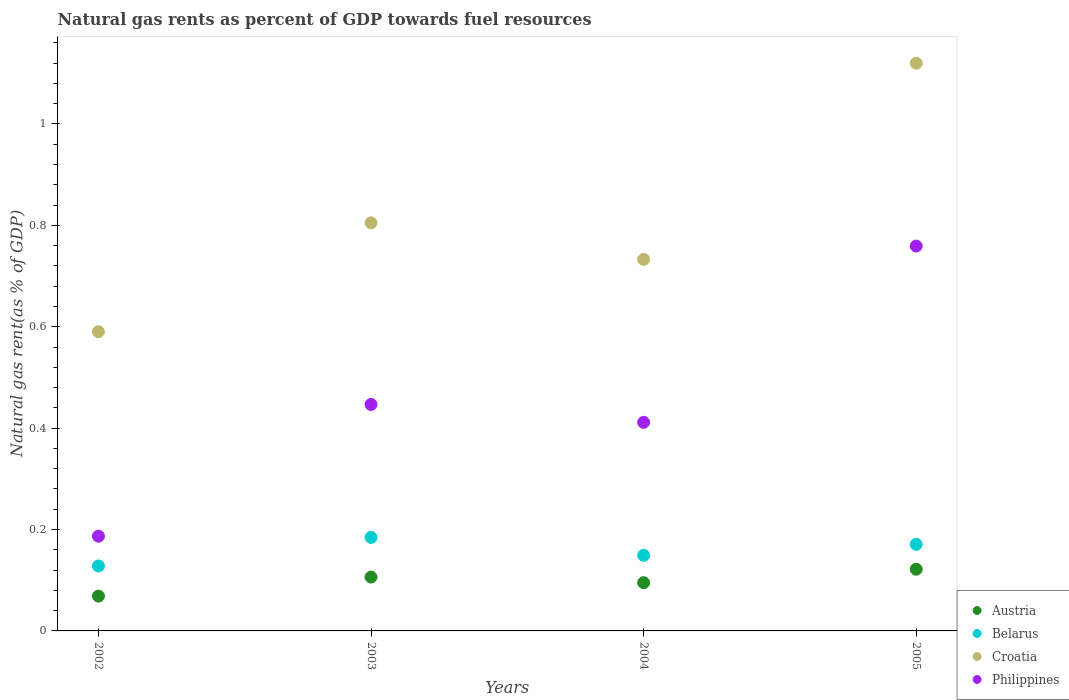Is the number of dotlines equal to the number of legend labels?
Keep it short and to the point. Yes. What is the natural gas rent in Austria in 2005?
Your answer should be compact. 0.12. Across all years, what is the maximum natural gas rent in Croatia?
Provide a short and direct response. 1.12. Across all years, what is the minimum natural gas rent in Belarus?
Ensure brevity in your answer.  0.13. In which year was the natural gas rent in Austria maximum?
Your answer should be very brief. 2005. What is the total natural gas rent in Croatia in the graph?
Provide a succinct answer. 3.25. What is the difference between the natural gas rent in Austria in 2003 and that in 2005?
Keep it short and to the point. -0.02. What is the difference between the natural gas rent in Belarus in 2003 and the natural gas rent in Croatia in 2005?
Make the answer very short. -0.94. What is the average natural gas rent in Austria per year?
Keep it short and to the point. 0.1. In the year 2004, what is the difference between the natural gas rent in Belarus and natural gas rent in Philippines?
Offer a terse response. -0.26. In how many years, is the natural gas rent in Croatia greater than 0.52 %?
Your answer should be compact. 4. What is the ratio of the natural gas rent in Philippines in 2003 to that in 2004?
Give a very brief answer. 1.09. Is the difference between the natural gas rent in Belarus in 2002 and 2004 greater than the difference between the natural gas rent in Philippines in 2002 and 2004?
Your response must be concise. Yes. What is the difference between the highest and the second highest natural gas rent in Austria?
Offer a terse response. 0.02. What is the difference between the highest and the lowest natural gas rent in Croatia?
Your response must be concise. 0.53. Is it the case that in every year, the sum of the natural gas rent in Austria and natural gas rent in Croatia  is greater than the sum of natural gas rent in Belarus and natural gas rent in Philippines?
Provide a succinct answer. Yes. Is it the case that in every year, the sum of the natural gas rent in Belarus and natural gas rent in Croatia  is greater than the natural gas rent in Austria?
Your response must be concise. Yes. How many dotlines are there?
Your response must be concise. 4. How many years are there in the graph?
Keep it short and to the point. 4. Does the graph contain grids?
Your answer should be very brief. No. How many legend labels are there?
Your answer should be very brief. 4. How are the legend labels stacked?
Keep it short and to the point. Vertical. What is the title of the graph?
Ensure brevity in your answer.  Natural gas rents as percent of GDP towards fuel resources. What is the label or title of the X-axis?
Keep it short and to the point. Years. What is the label or title of the Y-axis?
Provide a succinct answer. Natural gas rent(as % of GDP). What is the Natural gas rent(as % of GDP) in Austria in 2002?
Give a very brief answer. 0.07. What is the Natural gas rent(as % of GDP) in Belarus in 2002?
Offer a terse response. 0.13. What is the Natural gas rent(as % of GDP) of Croatia in 2002?
Your answer should be very brief. 0.59. What is the Natural gas rent(as % of GDP) in Philippines in 2002?
Ensure brevity in your answer.  0.19. What is the Natural gas rent(as % of GDP) of Austria in 2003?
Your response must be concise. 0.11. What is the Natural gas rent(as % of GDP) of Belarus in 2003?
Keep it short and to the point. 0.18. What is the Natural gas rent(as % of GDP) of Croatia in 2003?
Give a very brief answer. 0.8. What is the Natural gas rent(as % of GDP) in Philippines in 2003?
Your answer should be very brief. 0.45. What is the Natural gas rent(as % of GDP) in Austria in 2004?
Offer a very short reply. 0.1. What is the Natural gas rent(as % of GDP) in Belarus in 2004?
Ensure brevity in your answer.  0.15. What is the Natural gas rent(as % of GDP) of Croatia in 2004?
Your answer should be very brief. 0.73. What is the Natural gas rent(as % of GDP) of Philippines in 2004?
Your answer should be compact. 0.41. What is the Natural gas rent(as % of GDP) of Austria in 2005?
Offer a very short reply. 0.12. What is the Natural gas rent(as % of GDP) of Belarus in 2005?
Ensure brevity in your answer.  0.17. What is the Natural gas rent(as % of GDP) of Croatia in 2005?
Offer a terse response. 1.12. What is the Natural gas rent(as % of GDP) in Philippines in 2005?
Your answer should be compact. 0.76. Across all years, what is the maximum Natural gas rent(as % of GDP) in Austria?
Make the answer very short. 0.12. Across all years, what is the maximum Natural gas rent(as % of GDP) in Belarus?
Provide a short and direct response. 0.18. Across all years, what is the maximum Natural gas rent(as % of GDP) in Croatia?
Ensure brevity in your answer.  1.12. Across all years, what is the maximum Natural gas rent(as % of GDP) of Philippines?
Your answer should be very brief. 0.76. Across all years, what is the minimum Natural gas rent(as % of GDP) of Austria?
Your response must be concise. 0.07. Across all years, what is the minimum Natural gas rent(as % of GDP) in Belarus?
Your response must be concise. 0.13. Across all years, what is the minimum Natural gas rent(as % of GDP) of Croatia?
Ensure brevity in your answer.  0.59. Across all years, what is the minimum Natural gas rent(as % of GDP) in Philippines?
Provide a succinct answer. 0.19. What is the total Natural gas rent(as % of GDP) of Austria in the graph?
Your answer should be very brief. 0.39. What is the total Natural gas rent(as % of GDP) in Belarus in the graph?
Your answer should be compact. 0.63. What is the total Natural gas rent(as % of GDP) in Croatia in the graph?
Offer a terse response. 3.25. What is the total Natural gas rent(as % of GDP) in Philippines in the graph?
Your answer should be very brief. 1.8. What is the difference between the Natural gas rent(as % of GDP) in Austria in 2002 and that in 2003?
Give a very brief answer. -0.04. What is the difference between the Natural gas rent(as % of GDP) of Belarus in 2002 and that in 2003?
Your response must be concise. -0.06. What is the difference between the Natural gas rent(as % of GDP) of Croatia in 2002 and that in 2003?
Provide a succinct answer. -0.21. What is the difference between the Natural gas rent(as % of GDP) of Philippines in 2002 and that in 2003?
Your answer should be compact. -0.26. What is the difference between the Natural gas rent(as % of GDP) of Austria in 2002 and that in 2004?
Ensure brevity in your answer.  -0.03. What is the difference between the Natural gas rent(as % of GDP) in Belarus in 2002 and that in 2004?
Your response must be concise. -0.02. What is the difference between the Natural gas rent(as % of GDP) of Croatia in 2002 and that in 2004?
Your response must be concise. -0.14. What is the difference between the Natural gas rent(as % of GDP) of Philippines in 2002 and that in 2004?
Keep it short and to the point. -0.22. What is the difference between the Natural gas rent(as % of GDP) in Austria in 2002 and that in 2005?
Ensure brevity in your answer.  -0.05. What is the difference between the Natural gas rent(as % of GDP) in Belarus in 2002 and that in 2005?
Your answer should be very brief. -0.04. What is the difference between the Natural gas rent(as % of GDP) in Croatia in 2002 and that in 2005?
Ensure brevity in your answer.  -0.53. What is the difference between the Natural gas rent(as % of GDP) in Philippines in 2002 and that in 2005?
Keep it short and to the point. -0.57. What is the difference between the Natural gas rent(as % of GDP) of Austria in 2003 and that in 2004?
Make the answer very short. 0.01. What is the difference between the Natural gas rent(as % of GDP) of Belarus in 2003 and that in 2004?
Your answer should be compact. 0.04. What is the difference between the Natural gas rent(as % of GDP) of Croatia in 2003 and that in 2004?
Provide a short and direct response. 0.07. What is the difference between the Natural gas rent(as % of GDP) in Philippines in 2003 and that in 2004?
Provide a short and direct response. 0.04. What is the difference between the Natural gas rent(as % of GDP) in Austria in 2003 and that in 2005?
Make the answer very short. -0.02. What is the difference between the Natural gas rent(as % of GDP) of Belarus in 2003 and that in 2005?
Your answer should be compact. 0.01. What is the difference between the Natural gas rent(as % of GDP) of Croatia in 2003 and that in 2005?
Your answer should be very brief. -0.31. What is the difference between the Natural gas rent(as % of GDP) in Philippines in 2003 and that in 2005?
Give a very brief answer. -0.31. What is the difference between the Natural gas rent(as % of GDP) in Austria in 2004 and that in 2005?
Offer a very short reply. -0.03. What is the difference between the Natural gas rent(as % of GDP) of Belarus in 2004 and that in 2005?
Your answer should be very brief. -0.02. What is the difference between the Natural gas rent(as % of GDP) of Croatia in 2004 and that in 2005?
Your answer should be very brief. -0.39. What is the difference between the Natural gas rent(as % of GDP) in Philippines in 2004 and that in 2005?
Make the answer very short. -0.35. What is the difference between the Natural gas rent(as % of GDP) in Austria in 2002 and the Natural gas rent(as % of GDP) in Belarus in 2003?
Provide a succinct answer. -0.12. What is the difference between the Natural gas rent(as % of GDP) of Austria in 2002 and the Natural gas rent(as % of GDP) of Croatia in 2003?
Offer a very short reply. -0.74. What is the difference between the Natural gas rent(as % of GDP) in Austria in 2002 and the Natural gas rent(as % of GDP) in Philippines in 2003?
Provide a succinct answer. -0.38. What is the difference between the Natural gas rent(as % of GDP) of Belarus in 2002 and the Natural gas rent(as % of GDP) of Croatia in 2003?
Provide a short and direct response. -0.68. What is the difference between the Natural gas rent(as % of GDP) in Belarus in 2002 and the Natural gas rent(as % of GDP) in Philippines in 2003?
Offer a very short reply. -0.32. What is the difference between the Natural gas rent(as % of GDP) in Croatia in 2002 and the Natural gas rent(as % of GDP) in Philippines in 2003?
Provide a short and direct response. 0.14. What is the difference between the Natural gas rent(as % of GDP) in Austria in 2002 and the Natural gas rent(as % of GDP) in Belarus in 2004?
Your response must be concise. -0.08. What is the difference between the Natural gas rent(as % of GDP) in Austria in 2002 and the Natural gas rent(as % of GDP) in Croatia in 2004?
Ensure brevity in your answer.  -0.66. What is the difference between the Natural gas rent(as % of GDP) of Austria in 2002 and the Natural gas rent(as % of GDP) of Philippines in 2004?
Provide a succinct answer. -0.34. What is the difference between the Natural gas rent(as % of GDP) in Belarus in 2002 and the Natural gas rent(as % of GDP) in Croatia in 2004?
Your response must be concise. -0.6. What is the difference between the Natural gas rent(as % of GDP) of Belarus in 2002 and the Natural gas rent(as % of GDP) of Philippines in 2004?
Offer a terse response. -0.28. What is the difference between the Natural gas rent(as % of GDP) of Croatia in 2002 and the Natural gas rent(as % of GDP) of Philippines in 2004?
Make the answer very short. 0.18. What is the difference between the Natural gas rent(as % of GDP) of Austria in 2002 and the Natural gas rent(as % of GDP) of Belarus in 2005?
Make the answer very short. -0.1. What is the difference between the Natural gas rent(as % of GDP) of Austria in 2002 and the Natural gas rent(as % of GDP) of Croatia in 2005?
Keep it short and to the point. -1.05. What is the difference between the Natural gas rent(as % of GDP) of Austria in 2002 and the Natural gas rent(as % of GDP) of Philippines in 2005?
Your answer should be very brief. -0.69. What is the difference between the Natural gas rent(as % of GDP) of Belarus in 2002 and the Natural gas rent(as % of GDP) of Croatia in 2005?
Offer a very short reply. -0.99. What is the difference between the Natural gas rent(as % of GDP) in Belarus in 2002 and the Natural gas rent(as % of GDP) in Philippines in 2005?
Provide a short and direct response. -0.63. What is the difference between the Natural gas rent(as % of GDP) in Croatia in 2002 and the Natural gas rent(as % of GDP) in Philippines in 2005?
Your answer should be very brief. -0.17. What is the difference between the Natural gas rent(as % of GDP) of Austria in 2003 and the Natural gas rent(as % of GDP) of Belarus in 2004?
Provide a succinct answer. -0.04. What is the difference between the Natural gas rent(as % of GDP) of Austria in 2003 and the Natural gas rent(as % of GDP) of Croatia in 2004?
Give a very brief answer. -0.63. What is the difference between the Natural gas rent(as % of GDP) of Austria in 2003 and the Natural gas rent(as % of GDP) of Philippines in 2004?
Your answer should be compact. -0.31. What is the difference between the Natural gas rent(as % of GDP) of Belarus in 2003 and the Natural gas rent(as % of GDP) of Croatia in 2004?
Make the answer very short. -0.55. What is the difference between the Natural gas rent(as % of GDP) in Belarus in 2003 and the Natural gas rent(as % of GDP) in Philippines in 2004?
Your response must be concise. -0.23. What is the difference between the Natural gas rent(as % of GDP) in Croatia in 2003 and the Natural gas rent(as % of GDP) in Philippines in 2004?
Provide a short and direct response. 0.39. What is the difference between the Natural gas rent(as % of GDP) in Austria in 2003 and the Natural gas rent(as % of GDP) in Belarus in 2005?
Give a very brief answer. -0.06. What is the difference between the Natural gas rent(as % of GDP) in Austria in 2003 and the Natural gas rent(as % of GDP) in Croatia in 2005?
Your answer should be very brief. -1.01. What is the difference between the Natural gas rent(as % of GDP) of Austria in 2003 and the Natural gas rent(as % of GDP) of Philippines in 2005?
Give a very brief answer. -0.65. What is the difference between the Natural gas rent(as % of GDP) of Belarus in 2003 and the Natural gas rent(as % of GDP) of Croatia in 2005?
Provide a succinct answer. -0.94. What is the difference between the Natural gas rent(as % of GDP) in Belarus in 2003 and the Natural gas rent(as % of GDP) in Philippines in 2005?
Make the answer very short. -0.57. What is the difference between the Natural gas rent(as % of GDP) in Croatia in 2003 and the Natural gas rent(as % of GDP) in Philippines in 2005?
Give a very brief answer. 0.05. What is the difference between the Natural gas rent(as % of GDP) in Austria in 2004 and the Natural gas rent(as % of GDP) in Belarus in 2005?
Your response must be concise. -0.08. What is the difference between the Natural gas rent(as % of GDP) of Austria in 2004 and the Natural gas rent(as % of GDP) of Croatia in 2005?
Make the answer very short. -1.02. What is the difference between the Natural gas rent(as % of GDP) in Austria in 2004 and the Natural gas rent(as % of GDP) in Philippines in 2005?
Keep it short and to the point. -0.66. What is the difference between the Natural gas rent(as % of GDP) of Belarus in 2004 and the Natural gas rent(as % of GDP) of Croatia in 2005?
Keep it short and to the point. -0.97. What is the difference between the Natural gas rent(as % of GDP) in Belarus in 2004 and the Natural gas rent(as % of GDP) in Philippines in 2005?
Your answer should be compact. -0.61. What is the difference between the Natural gas rent(as % of GDP) of Croatia in 2004 and the Natural gas rent(as % of GDP) of Philippines in 2005?
Make the answer very short. -0.03. What is the average Natural gas rent(as % of GDP) of Austria per year?
Offer a terse response. 0.1. What is the average Natural gas rent(as % of GDP) of Belarus per year?
Give a very brief answer. 0.16. What is the average Natural gas rent(as % of GDP) of Croatia per year?
Provide a succinct answer. 0.81. What is the average Natural gas rent(as % of GDP) of Philippines per year?
Make the answer very short. 0.45. In the year 2002, what is the difference between the Natural gas rent(as % of GDP) of Austria and Natural gas rent(as % of GDP) of Belarus?
Ensure brevity in your answer.  -0.06. In the year 2002, what is the difference between the Natural gas rent(as % of GDP) in Austria and Natural gas rent(as % of GDP) in Croatia?
Keep it short and to the point. -0.52. In the year 2002, what is the difference between the Natural gas rent(as % of GDP) in Austria and Natural gas rent(as % of GDP) in Philippines?
Give a very brief answer. -0.12. In the year 2002, what is the difference between the Natural gas rent(as % of GDP) in Belarus and Natural gas rent(as % of GDP) in Croatia?
Make the answer very short. -0.46. In the year 2002, what is the difference between the Natural gas rent(as % of GDP) of Belarus and Natural gas rent(as % of GDP) of Philippines?
Your response must be concise. -0.06. In the year 2002, what is the difference between the Natural gas rent(as % of GDP) in Croatia and Natural gas rent(as % of GDP) in Philippines?
Your response must be concise. 0.4. In the year 2003, what is the difference between the Natural gas rent(as % of GDP) of Austria and Natural gas rent(as % of GDP) of Belarus?
Provide a short and direct response. -0.08. In the year 2003, what is the difference between the Natural gas rent(as % of GDP) in Austria and Natural gas rent(as % of GDP) in Croatia?
Make the answer very short. -0.7. In the year 2003, what is the difference between the Natural gas rent(as % of GDP) of Austria and Natural gas rent(as % of GDP) of Philippines?
Offer a very short reply. -0.34. In the year 2003, what is the difference between the Natural gas rent(as % of GDP) of Belarus and Natural gas rent(as % of GDP) of Croatia?
Your response must be concise. -0.62. In the year 2003, what is the difference between the Natural gas rent(as % of GDP) in Belarus and Natural gas rent(as % of GDP) in Philippines?
Give a very brief answer. -0.26. In the year 2003, what is the difference between the Natural gas rent(as % of GDP) in Croatia and Natural gas rent(as % of GDP) in Philippines?
Make the answer very short. 0.36. In the year 2004, what is the difference between the Natural gas rent(as % of GDP) of Austria and Natural gas rent(as % of GDP) of Belarus?
Offer a very short reply. -0.05. In the year 2004, what is the difference between the Natural gas rent(as % of GDP) of Austria and Natural gas rent(as % of GDP) of Croatia?
Offer a terse response. -0.64. In the year 2004, what is the difference between the Natural gas rent(as % of GDP) of Austria and Natural gas rent(as % of GDP) of Philippines?
Make the answer very short. -0.32. In the year 2004, what is the difference between the Natural gas rent(as % of GDP) in Belarus and Natural gas rent(as % of GDP) in Croatia?
Keep it short and to the point. -0.58. In the year 2004, what is the difference between the Natural gas rent(as % of GDP) in Belarus and Natural gas rent(as % of GDP) in Philippines?
Your answer should be compact. -0.26. In the year 2004, what is the difference between the Natural gas rent(as % of GDP) in Croatia and Natural gas rent(as % of GDP) in Philippines?
Your answer should be compact. 0.32. In the year 2005, what is the difference between the Natural gas rent(as % of GDP) in Austria and Natural gas rent(as % of GDP) in Belarus?
Provide a short and direct response. -0.05. In the year 2005, what is the difference between the Natural gas rent(as % of GDP) in Austria and Natural gas rent(as % of GDP) in Croatia?
Provide a short and direct response. -1. In the year 2005, what is the difference between the Natural gas rent(as % of GDP) of Austria and Natural gas rent(as % of GDP) of Philippines?
Your answer should be very brief. -0.64. In the year 2005, what is the difference between the Natural gas rent(as % of GDP) in Belarus and Natural gas rent(as % of GDP) in Croatia?
Give a very brief answer. -0.95. In the year 2005, what is the difference between the Natural gas rent(as % of GDP) in Belarus and Natural gas rent(as % of GDP) in Philippines?
Give a very brief answer. -0.59. In the year 2005, what is the difference between the Natural gas rent(as % of GDP) in Croatia and Natural gas rent(as % of GDP) in Philippines?
Ensure brevity in your answer.  0.36. What is the ratio of the Natural gas rent(as % of GDP) of Austria in 2002 to that in 2003?
Give a very brief answer. 0.65. What is the ratio of the Natural gas rent(as % of GDP) of Belarus in 2002 to that in 2003?
Provide a succinct answer. 0.69. What is the ratio of the Natural gas rent(as % of GDP) in Croatia in 2002 to that in 2003?
Offer a very short reply. 0.73. What is the ratio of the Natural gas rent(as % of GDP) of Philippines in 2002 to that in 2003?
Your answer should be very brief. 0.42. What is the ratio of the Natural gas rent(as % of GDP) in Austria in 2002 to that in 2004?
Keep it short and to the point. 0.72. What is the ratio of the Natural gas rent(as % of GDP) in Belarus in 2002 to that in 2004?
Your answer should be compact. 0.86. What is the ratio of the Natural gas rent(as % of GDP) in Croatia in 2002 to that in 2004?
Offer a terse response. 0.81. What is the ratio of the Natural gas rent(as % of GDP) in Philippines in 2002 to that in 2004?
Offer a very short reply. 0.45. What is the ratio of the Natural gas rent(as % of GDP) of Austria in 2002 to that in 2005?
Your answer should be very brief. 0.56. What is the ratio of the Natural gas rent(as % of GDP) of Belarus in 2002 to that in 2005?
Keep it short and to the point. 0.75. What is the ratio of the Natural gas rent(as % of GDP) of Croatia in 2002 to that in 2005?
Your answer should be compact. 0.53. What is the ratio of the Natural gas rent(as % of GDP) of Philippines in 2002 to that in 2005?
Ensure brevity in your answer.  0.25. What is the ratio of the Natural gas rent(as % of GDP) in Austria in 2003 to that in 2004?
Offer a very short reply. 1.12. What is the ratio of the Natural gas rent(as % of GDP) in Belarus in 2003 to that in 2004?
Your answer should be very brief. 1.24. What is the ratio of the Natural gas rent(as % of GDP) in Croatia in 2003 to that in 2004?
Your response must be concise. 1.1. What is the ratio of the Natural gas rent(as % of GDP) of Philippines in 2003 to that in 2004?
Offer a very short reply. 1.09. What is the ratio of the Natural gas rent(as % of GDP) of Austria in 2003 to that in 2005?
Your answer should be very brief. 0.87. What is the ratio of the Natural gas rent(as % of GDP) of Croatia in 2003 to that in 2005?
Give a very brief answer. 0.72. What is the ratio of the Natural gas rent(as % of GDP) of Philippines in 2003 to that in 2005?
Make the answer very short. 0.59. What is the ratio of the Natural gas rent(as % of GDP) in Austria in 2004 to that in 2005?
Keep it short and to the point. 0.78. What is the ratio of the Natural gas rent(as % of GDP) of Belarus in 2004 to that in 2005?
Ensure brevity in your answer.  0.87. What is the ratio of the Natural gas rent(as % of GDP) of Croatia in 2004 to that in 2005?
Offer a terse response. 0.65. What is the ratio of the Natural gas rent(as % of GDP) in Philippines in 2004 to that in 2005?
Your response must be concise. 0.54. What is the difference between the highest and the second highest Natural gas rent(as % of GDP) in Austria?
Offer a very short reply. 0.02. What is the difference between the highest and the second highest Natural gas rent(as % of GDP) of Belarus?
Your answer should be compact. 0.01. What is the difference between the highest and the second highest Natural gas rent(as % of GDP) of Croatia?
Your answer should be very brief. 0.31. What is the difference between the highest and the second highest Natural gas rent(as % of GDP) of Philippines?
Your response must be concise. 0.31. What is the difference between the highest and the lowest Natural gas rent(as % of GDP) of Austria?
Keep it short and to the point. 0.05. What is the difference between the highest and the lowest Natural gas rent(as % of GDP) of Belarus?
Your response must be concise. 0.06. What is the difference between the highest and the lowest Natural gas rent(as % of GDP) in Croatia?
Give a very brief answer. 0.53. What is the difference between the highest and the lowest Natural gas rent(as % of GDP) of Philippines?
Provide a succinct answer. 0.57. 